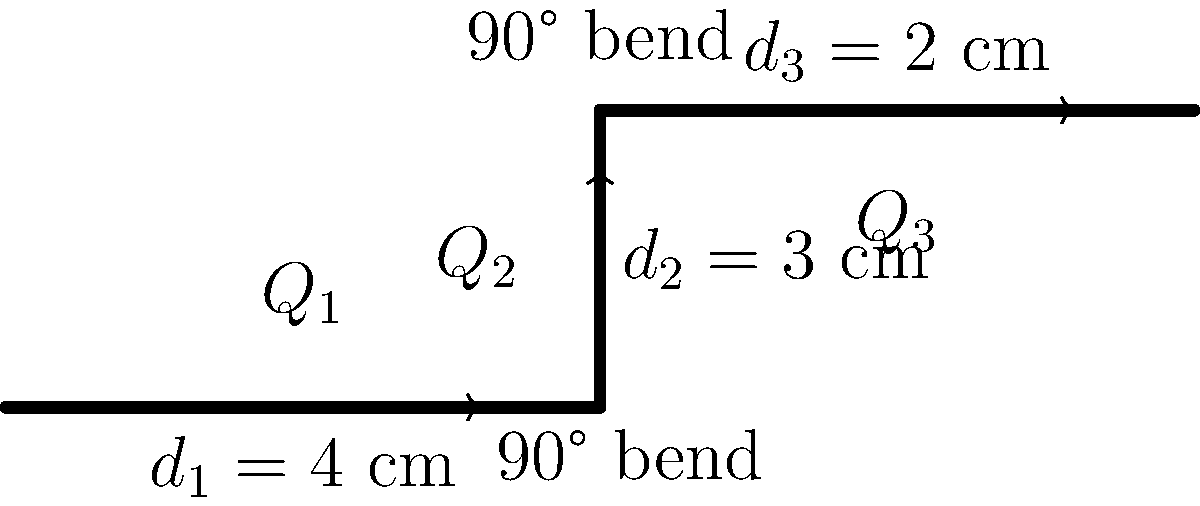In a classic rock recording studio, you encounter a unique water cooling system for the vintage equipment. The system consists of three connected pipes with different diameters: $d_1 = 4$ cm, $d_2 = 3$ cm, and $d_3 = 2$ cm. The pipes are connected by two 90° bends. If the flow rate in the first pipe ($Q_1$) is 100 L/min, calculate the flow rate in the third pipe ($Q_3$) assuming incompressible flow and no leakage. To solve this problem, we'll use the concept of conservation of mass for incompressible flow. The steps are as follows:

1. Recognize that for incompressible flow with no leakage, the volumetric flow rate remains constant throughout the system.

2. Express this mathematically:
   $$Q_1 = Q_2 = Q_3 = Q$$

3. Given:
   $Q_1 = 100$ L/min

4. Convert the flow rate to m³/s for consistency with SI units:
   $$Q = 100 \text{ L/min} \times \frac{1 \text{ m}^3}{1000 \text{ L}} \times \frac{1 \text{ min}}{60 \text{ s}} = 1.667 \times 10^{-3} \text{ m}^3/\text{s}$$

5. Since $Q_3 = Q_1$, we can conclude that:
   $$Q_3 = 1.667 \times 10^{-3} \text{ m}^3/\text{s}$$

6. Convert back to L/min:
   $$Q_3 = 1.667 \times 10^{-3} \text{ m}^3/\text{s} \times \frac{1000 \text{ L}}{1 \text{ m}^3} \times \frac{60 \text{ s}}{1 \text{ min}} = 100 \text{ L/min}$$

Therefore, the flow rate in the third pipe ($Q_3$) is 100 L/min, the same as in the first pipe.
Answer: 100 L/min 